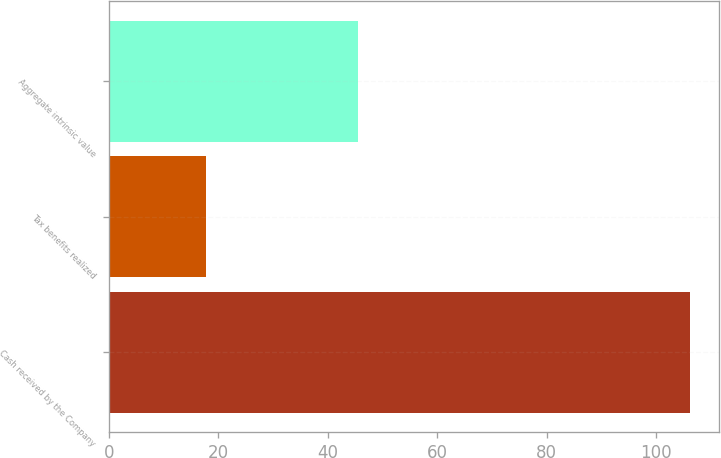Convert chart to OTSL. <chart><loc_0><loc_0><loc_500><loc_500><bar_chart><fcel>Cash received by the Company<fcel>Tax benefits realized<fcel>Aggregate intrinsic value<nl><fcel>106.1<fcel>17.7<fcel>45.5<nl></chart> 